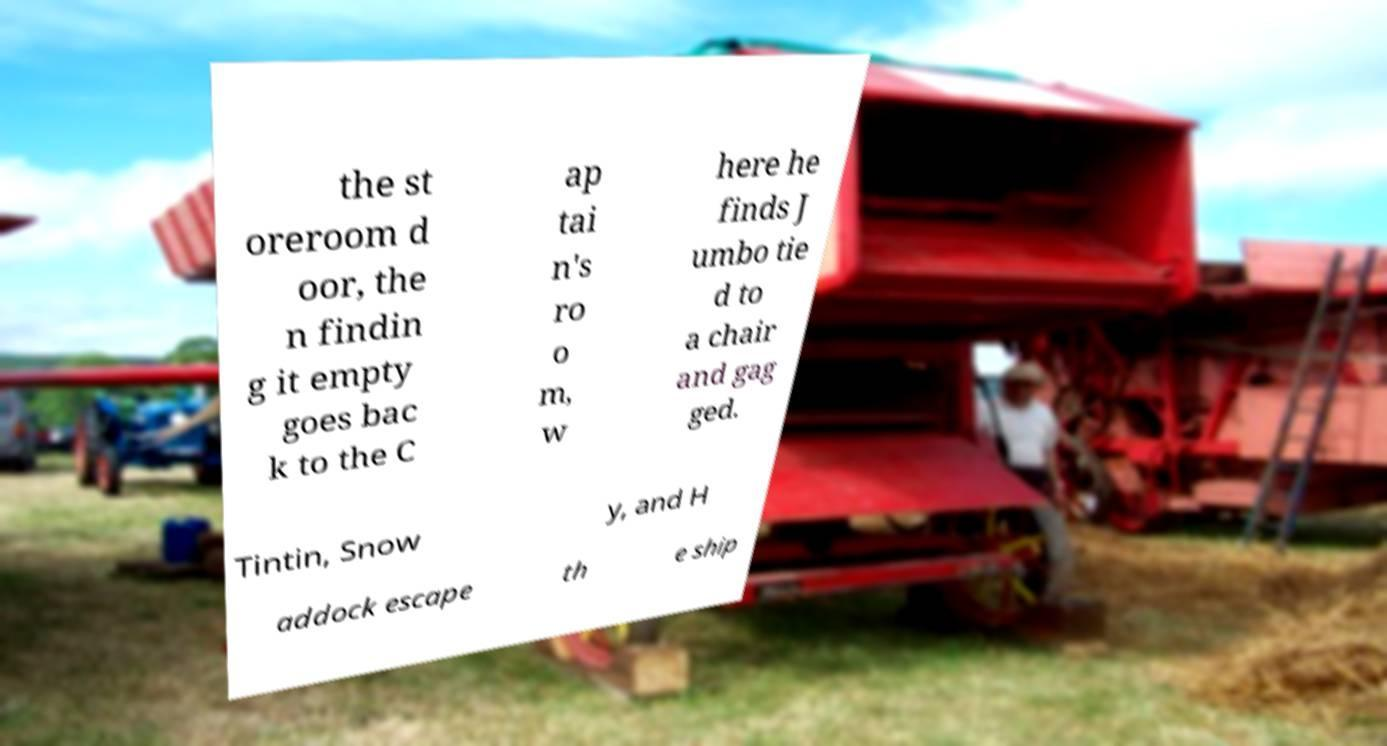Please identify and transcribe the text found in this image. the st oreroom d oor, the n findin g it empty goes bac k to the C ap tai n's ro o m, w here he finds J umbo tie d to a chair and gag ged. Tintin, Snow y, and H addock escape th e ship 